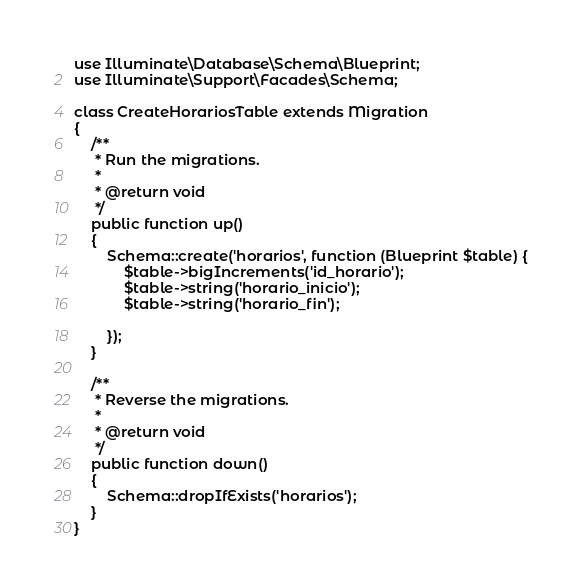<code> <loc_0><loc_0><loc_500><loc_500><_PHP_>use Illuminate\Database\Schema\Blueprint;
use Illuminate\Support\Facades\Schema;

class CreateHorariosTable extends Migration
{
    /**
     * Run the migrations.
     *
     * @return void
     */
    public function up()
    {
        Schema::create('horarios', function (Blueprint $table) {
            $table->bigIncrements('id_horario');
            $table->string('horario_inicio');
            $table->string('horario_fin');
            
        });
    }

    /**
     * Reverse the migrations.
     *
     * @return void
     */
    public function down()
    {
        Schema::dropIfExists('horarios');
    }
}
</code> 